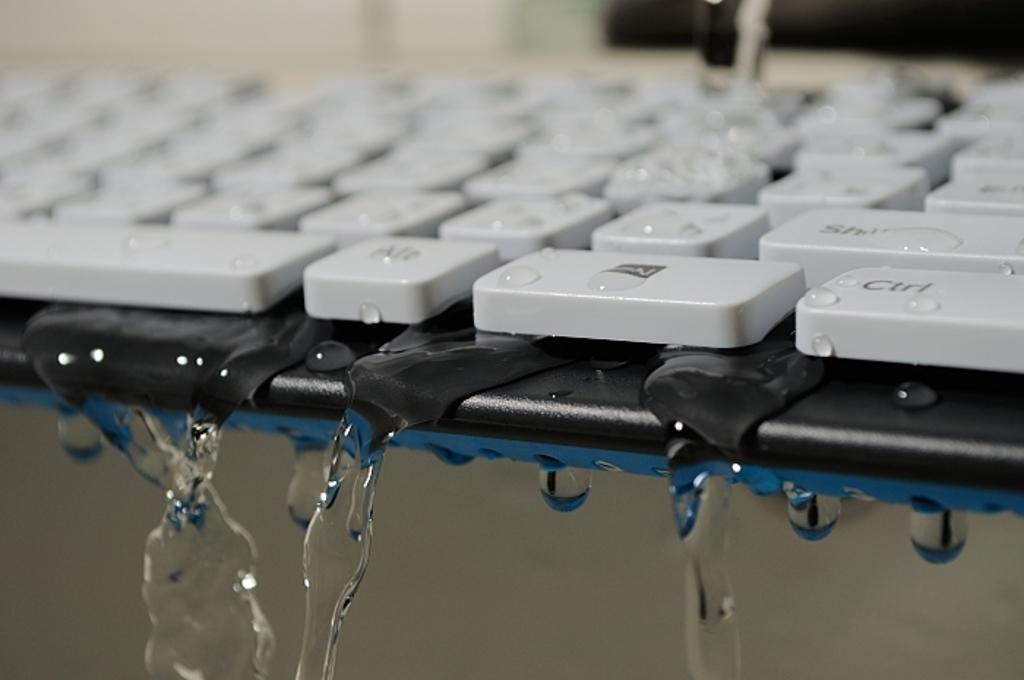What key is shown on the bottom right?
Offer a very short reply. Ctrl. What key is above the "ctrl" key?
Ensure brevity in your answer.  Shift. 